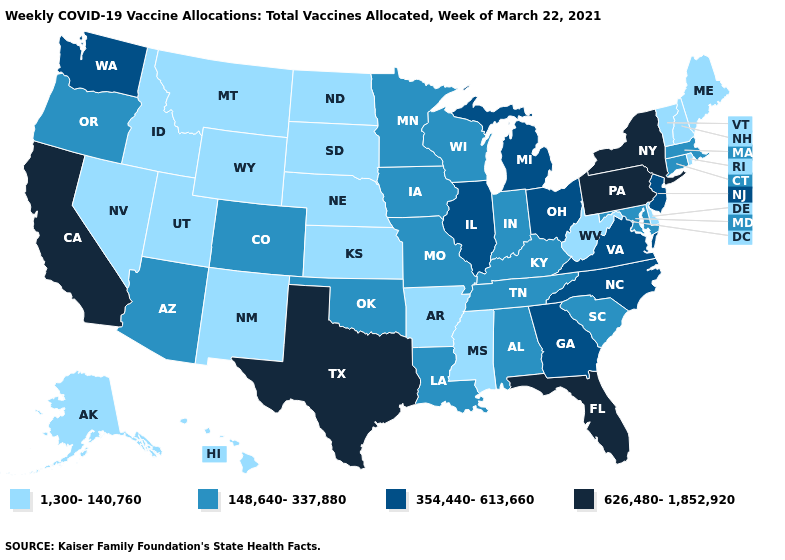Among the states that border Wyoming , which have the lowest value?
Answer briefly. Idaho, Montana, Nebraska, South Dakota, Utah. What is the value of New Hampshire?
Be succinct. 1,300-140,760. Does the map have missing data?
Answer briefly. No. Does Minnesota have the highest value in the MidWest?
Concise answer only. No. Name the states that have a value in the range 626,480-1,852,920?
Keep it brief. California, Florida, New York, Pennsylvania, Texas. Does Oklahoma have a lower value than New Jersey?
Concise answer only. Yes. Name the states that have a value in the range 148,640-337,880?
Quick response, please. Alabama, Arizona, Colorado, Connecticut, Indiana, Iowa, Kentucky, Louisiana, Maryland, Massachusetts, Minnesota, Missouri, Oklahoma, Oregon, South Carolina, Tennessee, Wisconsin. Name the states that have a value in the range 1,300-140,760?
Answer briefly. Alaska, Arkansas, Delaware, Hawaii, Idaho, Kansas, Maine, Mississippi, Montana, Nebraska, Nevada, New Hampshire, New Mexico, North Dakota, Rhode Island, South Dakota, Utah, Vermont, West Virginia, Wyoming. Does the map have missing data?
Give a very brief answer. No. What is the lowest value in states that border Washington?
Short answer required. 1,300-140,760. What is the value of Tennessee?
Keep it brief. 148,640-337,880. What is the value of Vermont?
Concise answer only. 1,300-140,760. Name the states that have a value in the range 354,440-613,660?
Give a very brief answer. Georgia, Illinois, Michigan, New Jersey, North Carolina, Ohio, Virginia, Washington. What is the lowest value in the Northeast?
Concise answer only. 1,300-140,760. Name the states that have a value in the range 354,440-613,660?
Short answer required. Georgia, Illinois, Michigan, New Jersey, North Carolina, Ohio, Virginia, Washington. 